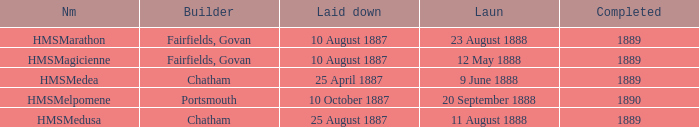What is the name of the boat that was built by Chatham and Laid down of 25 april 1887? HMSMedea. 